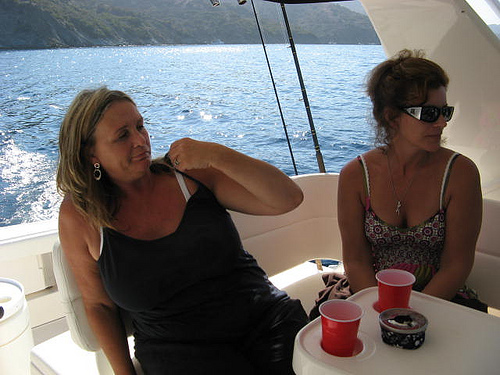<image>
Can you confirm if the small girl is to the left of the white girl? Yes. From this viewpoint, the small girl is positioned to the left side relative to the white girl. 